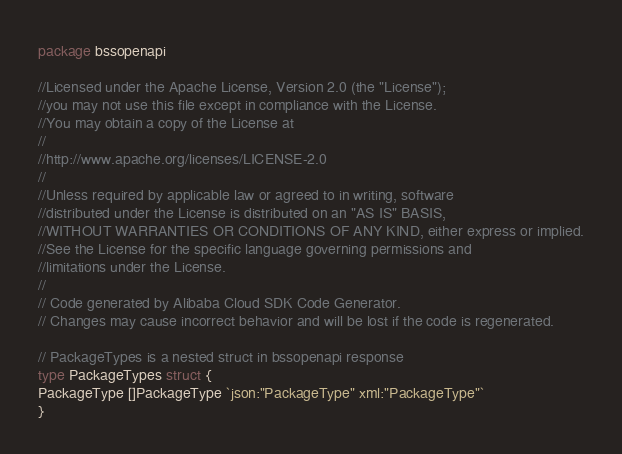<code> <loc_0><loc_0><loc_500><loc_500><_Go_>
package bssopenapi

//Licensed under the Apache License, Version 2.0 (the "License");
//you may not use this file except in compliance with the License.
//You may obtain a copy of the License at
//
//http://www.apache.org/licenses/LICENSE-2.0
//
//Unless required by applicable law or agreed to in writing, software
//distributed under the License is distributed on an "AS IS" BASIS,
//WITHOUT WARRANTIES OR CONDITIONS OF ANY KIND, either express or implied.
//See the License for the specific language governing permissions and
//limitations under the License.
//
// Code generated by Alibaba Cloud SDK Code Generator.
// Changes may cause incorrect behavior and will be lost if the code is regenerated.

// PackageTypes is a nested struct in bssopenapi response
type PackageTypes struct {
PackageType []PackageType `json:"PackageType" xml:"PackageType"`
}
</code> 